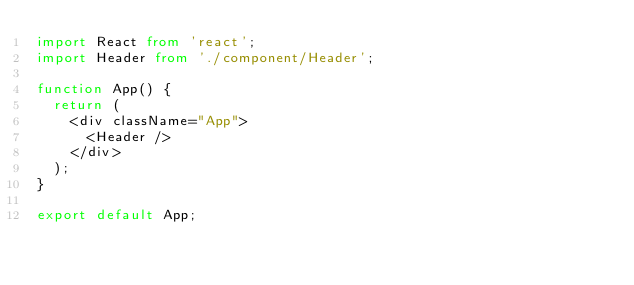<code> <loc_0><loc_0><loc_500><loc_500><_TypeScript_>import React from 'react';
import Header from './component/Header';

function App() {
  return (
    <div className="App">
      <Header />
    </div>
  );
}

export default App;
</code> 